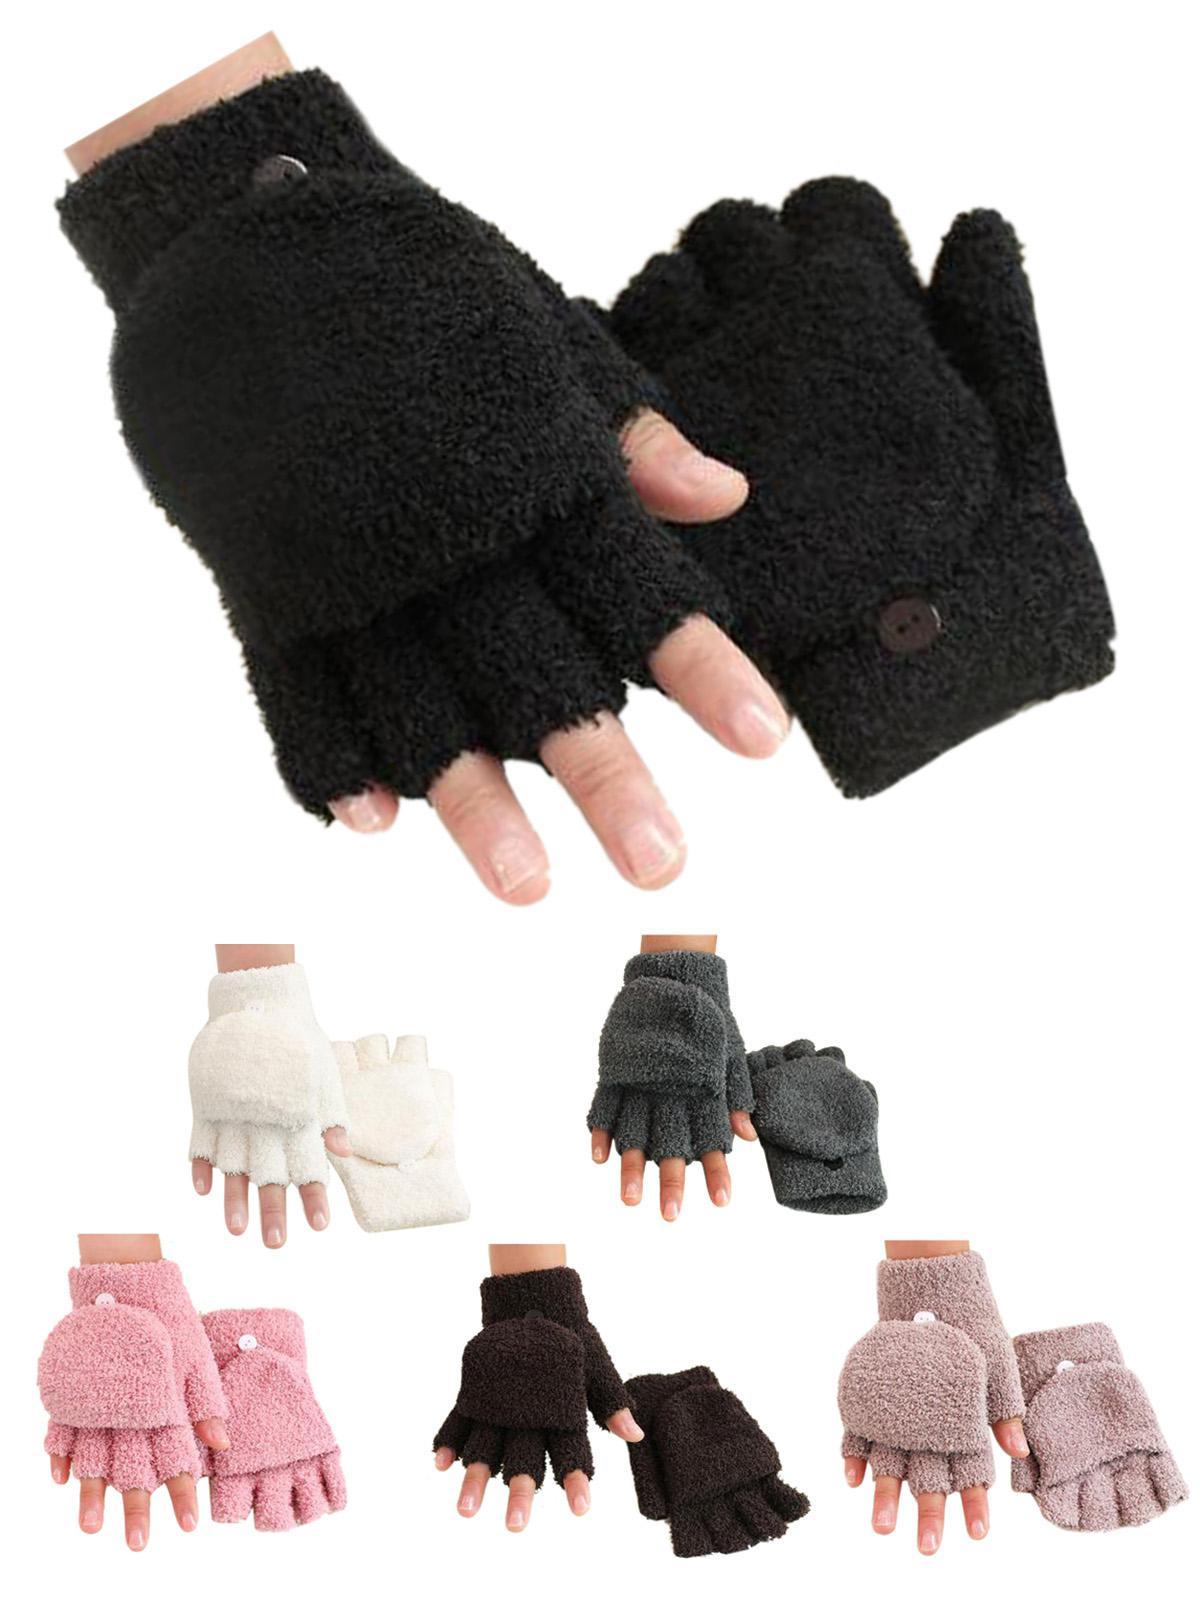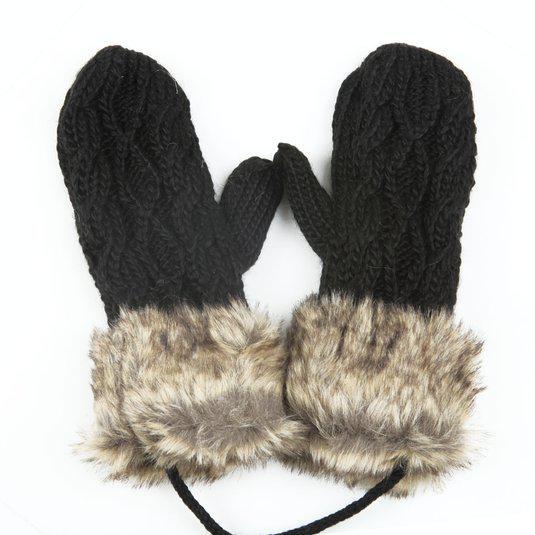The first image is the image on the left, the second image is the image on the right. Given the left and right images, does the statement "One image includes at least one pair of half-finger gloves with a mitten flap, and the other image shows one pair of knit mittens with fur cuffs at the wrists." hold true? Answer yes or no. Yes. The first image is the image on the left, the second image is the image on the right. Given the left and right images, does the statement "Only one of the images shows convertible mittens." hold true? Answer yes or no. Yes. 